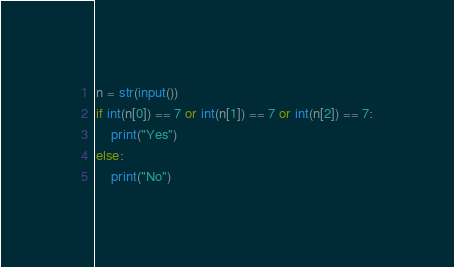<code> <loc_0><loc_0><loc_500><loc_500><_Python_>n = str(input())
if int(n[0]) == 7 or int(n[1]) == 7 or int(n[2]) == 7:
    print("Yes")
else:
    print("No")</code> 